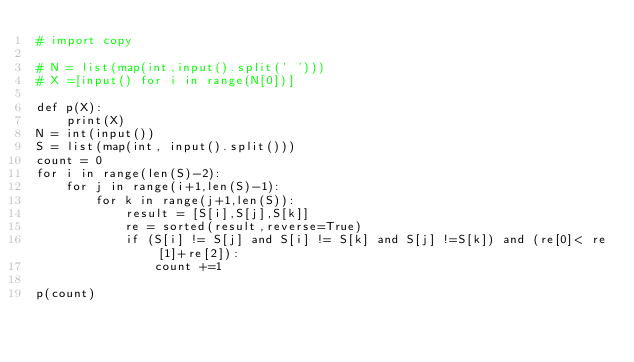Convert code to text. <code><loc_0><loc_0><loc_500><loc_500><_Python_># import copy

# N = list(map(int,input().split(' ')))
# X =[input() for i in range(N[0])] 

def p(X):
    print(X)
N = int(input())
S = list(map(int, input().split()))
count = 0
for i in range(len(S)-2):
    for j in range(i+1,len(S)-1):
        for k in range(j+1,len(S)):
            result = [S[i],S[j],S[k]]
            re = sorted(result,reverse=True)
            if (S[i] != S[j] and S[i] != S[k] and S[j] !=S[k]) and (re[0]< re[1]+re[2]):
                count +=1

p(count)

</code> 